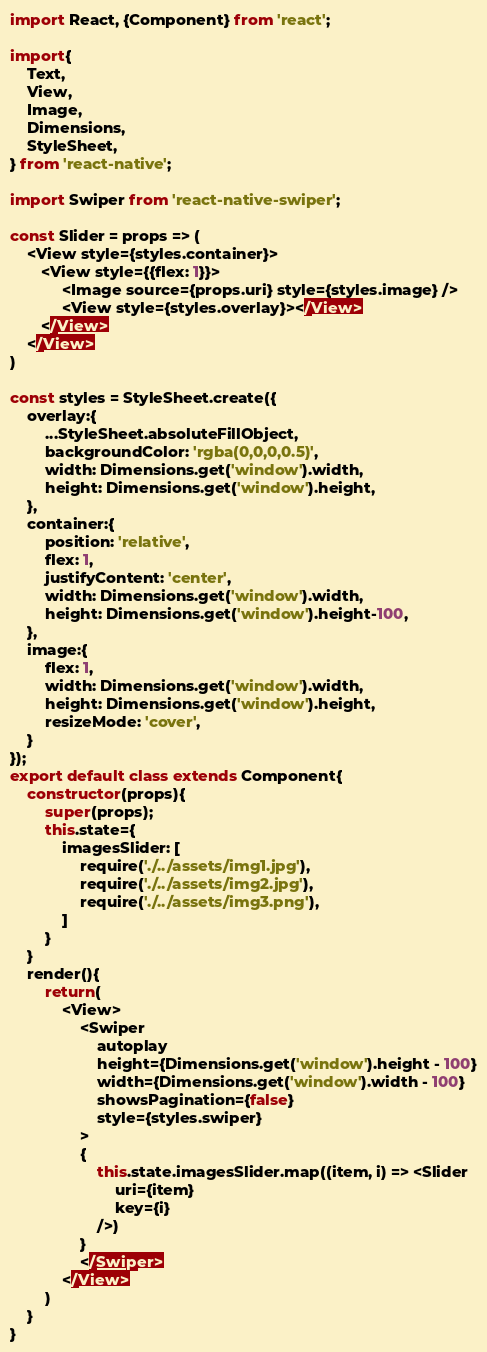<code> <loc_0><loc_0><loc_500><loc_500><_JavaScript_>import React, {Component} from 'react';

import{
    Text,
    View,
    Image,
    Dimensions,
    StyleSheet,
} from 'react-native';

import Swiper from 'react-native-swiper';

const Slider = props => (
    <View style={styles.container}>
       <View style={{flex: 1}}>
            <Image source={props.uri} style={styles.image} />
            <View style={styles.overlay}></View>
       </View>
    </View>
)

const styles = StyleSheet.create({
    overlay:{
        ...StyleSheet.absoluteFillObject,
        backgroundColor: 'rgba(0,0,0,0.5)',
        width: Dimensions.get('window').width,
        height: Dimensions.get('window').height,
    },
    container:{
        position: 'relative',
        flex: 1,
        justifyContent: 'center',
        width: Dimensions.get('window').width,
        height: Dimensions.get('window').height-100,
    },
    image:{
        flex: 1,
        width: Dimensions.get('window').width,
        height: Dimensions.get('window').height,
        resizeMode: 'cover',
    }
});
export default class extends Component{
    constructor(props){
        super(props);
        this.state={
            imagesSlider: [
                require('./../assets/img1.jpg'),
                require('./../assets/img2.jpg'),
                require('./../assets/img3.png'),
            ]
        }
    }
    render(){
        return(
            <View>
                <Swiper
                    autoplay
                    height={Dimensions.get('window').height - 100}
                    width={Dimensions.get('window').width - 100}
                    showsPagination={false}
                    style={styles.swiper}
                >
                {
                    this.state.imagesSlider.map((item, i) => <Slider
                        uri={item}
                        key={i}
                    />)
                }
                </Swiper>
            </View>
        )
    }
}</code> 